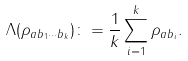<formula> <loc_0><loc_0><loc_500><loc_500>\Lambda ( \rho _ { a b _ { 1 } \cdots b _ { k } } ) \colon = \frac { 1 } { k } \sum _ { i = 1 } ^ { k } \rho _ { a b _ { i } } .</formula> 